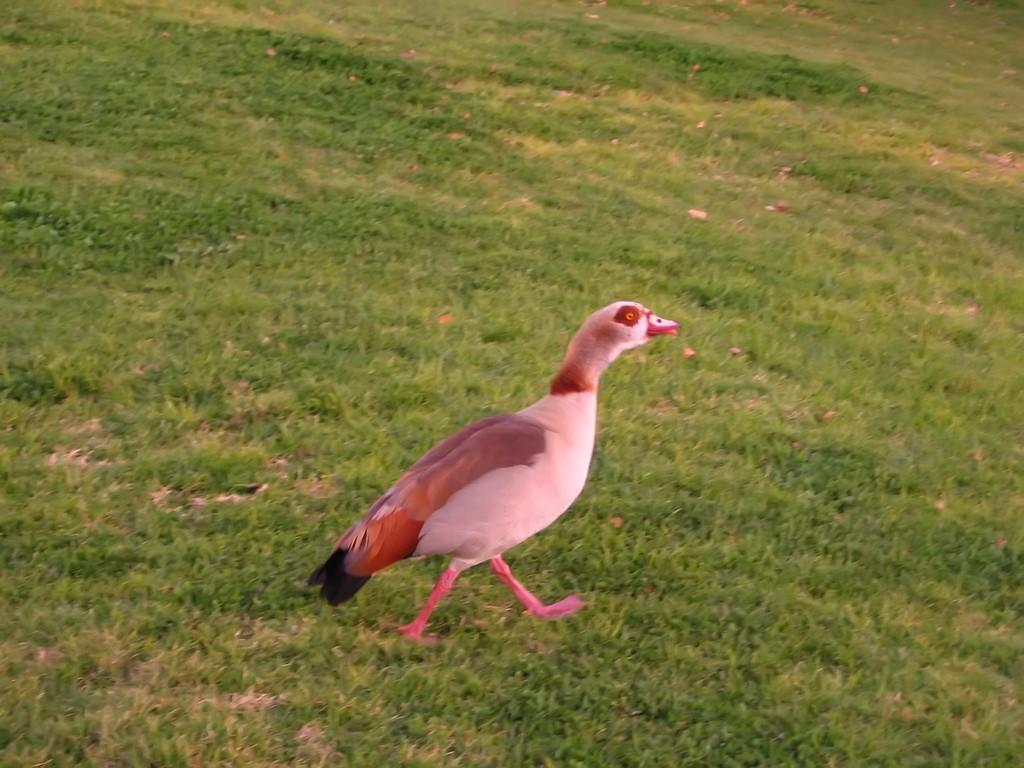What type of animal can be seen in the image? There is a bird in the image. What is the terrain like in the image? The land is covered with grass. Can you tell me how many basketballs are visible in the image? There are no basketballs present in the image. What type of fruit is growing on the grass in the image? There is no fruit, specifically quince, growing on the grass in the image. 